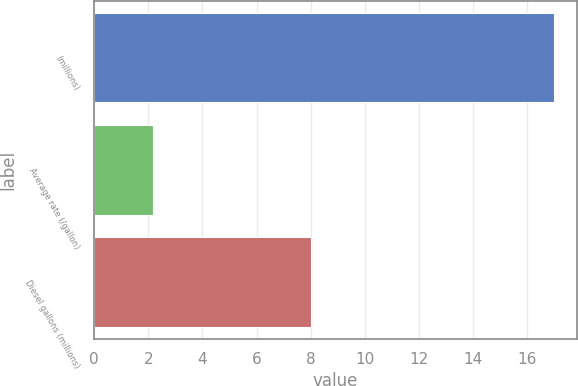Convert chart. <chart><loc_0><loc_0><loc_500><loc_500><bar_chart><fcel>(millions)<fcel>Average rate (/gallon)<fcel>Diesel gallons (millions)<nl><fcel>17<fcel>2.17<fcel>8<nl></chart> 